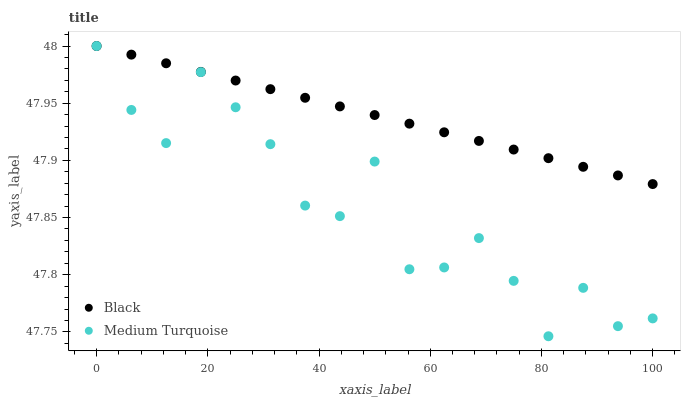Does Medium Turquoise have the minimum area under the curve?
Answer yes or no. Yes. Does Black have the maximum area under the curve?
Answer yes or no. Yes. Does Medium Turquoise have the maximum area under the curve?
Answer yes or no. No. Is Black the smoothest?
Answer yes or no. Yes. Is Medium Turquoise the roughest?
Answer yes or no. Yes. Is Medium Turquoise the smoothest?
Answer yes or no. No. Does Medium Turquoise have the lowest value?
Answer yes or no. Yes. Does Medium Turquoise have the highest value?
Answer yes or no. Yes. Does Black intersect Medium Turquoise?
Answer yes or no. Yes. Is Black less than Medium Turquoise?
Answer yes or no. No. Is Black greater than Medium Turquoise?
Answer yes or no. No. 